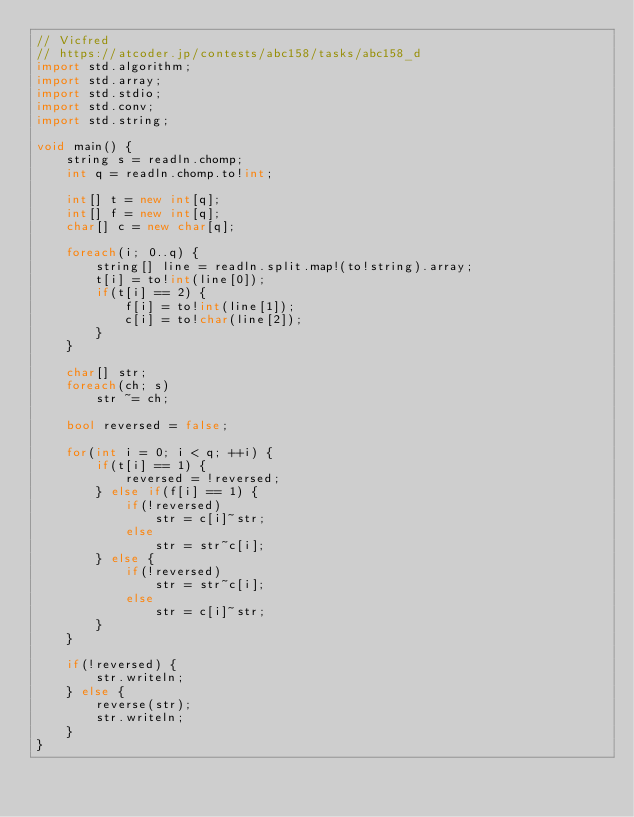<code> <loc_0><loc_0><loc_500><loc_500><_D_>// Vicfred
// https://atcoder.jp/contests/abc158/tasks/abc158_d
import std.algorithm;
import std.array;
import std.stdio;
import std.conv;
import std.string;

void main() {
    string s = readln.chomp;
    int q = readln.chomp.to!int;

    int[] t = new int[q];
    int[] f = new int[q];
    char[] c = new char[q];

    foreach(i; 0..q) {
        string[] line = readln.split.map!(to!string).array;
        t[i] = to!int(line[0]);
        if(t[i] == 2) {
            f[i] = to!int(line[1]);
            c[i] = to!char(line[2]);
        }
    }

    char[] str;
    foreach(ch; s)
        str ~= ch;

    bool reversed = false;

    for(int i = 0; i < q; ++i) {
        if(t[i] == 1) {
            reversed = !reversed;
        } else if(f[i] == 1) {
            if(!reversed)
                str = c[i]~str;
            else
                str = str~c[i];
        } else {
            if(!reversed)
                str = str~c[i];
            else
                str = c[i]~str;
        }
    }

    if(!reversed) {
        str.writeln;
    } else {
        reverse(str);
        str.writeln;
    }
}

</code> 